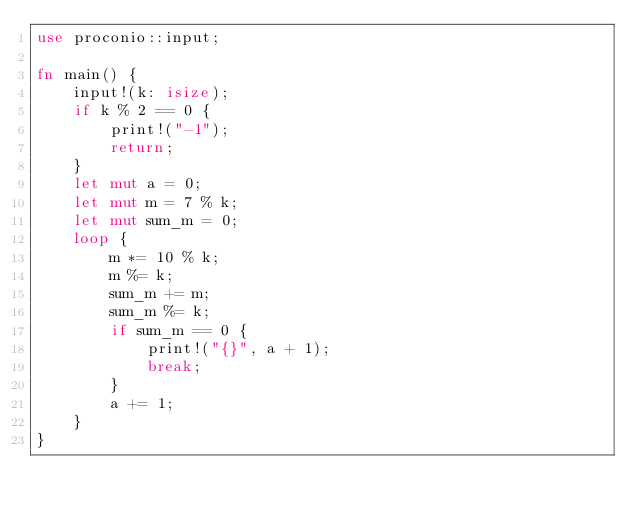<code> <loc_0><loc_0><loc_500><loc_500><_Rust_>use proconio::input;

fn main() {
    input!(k: isize);
    if k % 2 == 0 {
        print!("-1");
        return;
    }
    let mut a = 0;
    let mut m = 7 % k;
    let mut sum_m = 0;
    loop {
        m *= 10 % k;
        m %= k;
        sum_m += m;
        sum_m %= k;
        if sum_m == 0 {
            print!("{}", a + 1);
            break;
        }
        a += 1;
    }
}
</code> 